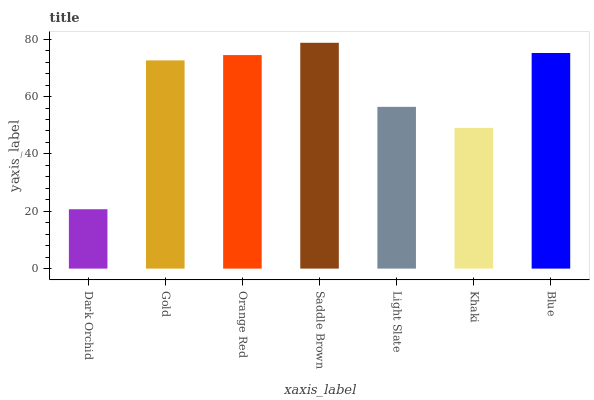Is Dark Orchid the minimum?
Answer yes or no. Yes. Is Saddle Brown the maximum?
Answer yes or no. Yes. Is Gold the minimum?
Answer yes or no. No. Is Gold the maximum?
Answer yes or no. No. Is Gold greater than Dark Orchid?
Answer yes or no. Yes. Is Dark Orchid less than Gold?
Answer yes or no. Yes. Is Dark Orchid greater than Gold?
Answer yes or no. No. Is Gold less than Dark Orchid?
Answer yes or no. No. Is Gold the high median?
Answer yes or no. Yes. Is Gold the low median?
Answer yes or no. Yes. Is Dark Orchid the high median?
Answer yes or no. No. Is Saddle Brown the low median?
Answer yes or no. No. 